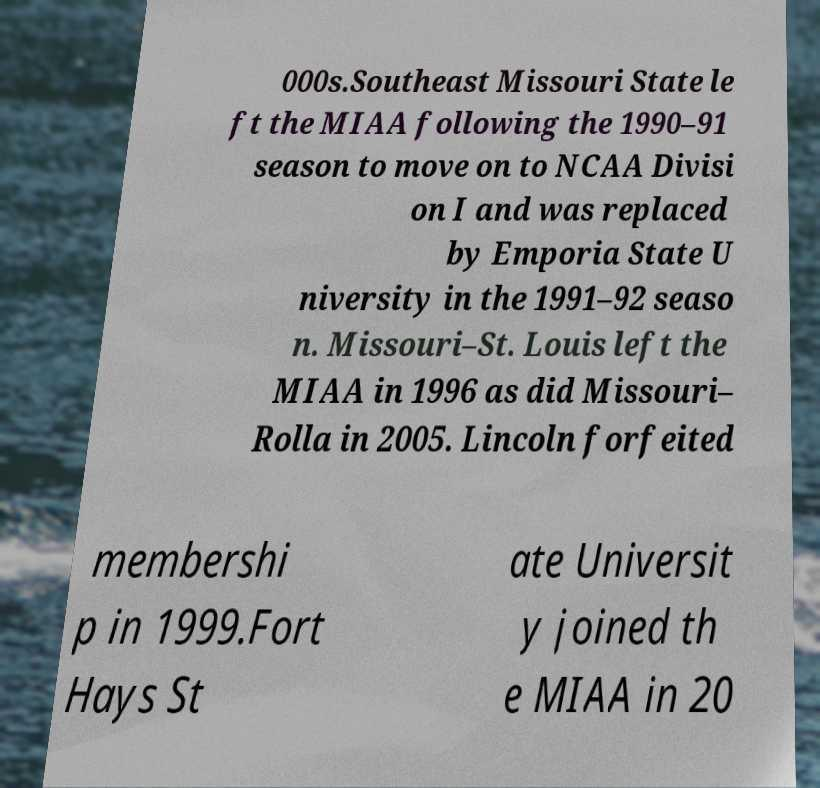I need the written content from this picture converted into text. Can you do that? 000s.Southeast Missouri State le ft the MIAA following the 1990–91 season to move on to NCAA Divisi on I and was replaced by Emporia State U niversity in the 1991–92 seaso n. Missouri–St. Louis left the MIAA in 1996 as did Missouri– Rolla in 2005. Lincoln forfeited membershi p in 1999.Fort Hays St ate Universit y joined th e MIAA in 20 